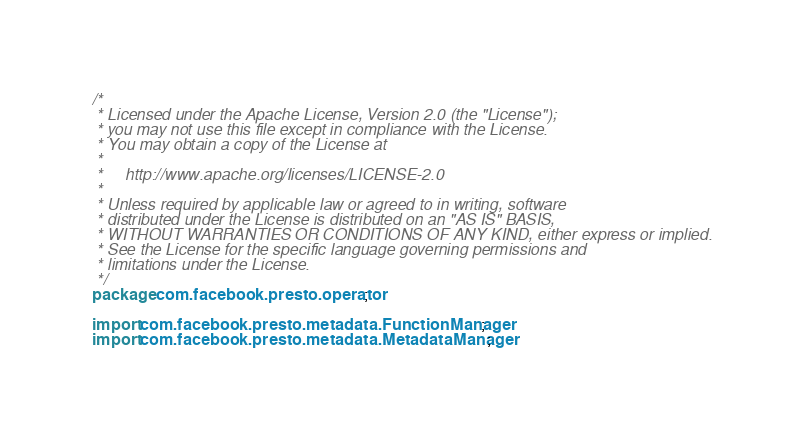<code> <loc_0><loc_0><loc_500><loc_500><_Java_>/*
 * Licensed under the Apache License, Version 2.0 (the "License");
 * you may not use this file except in compliance with the License.
 * You may obtain a copy of the License at
 *
 *     http://www.apache.org/licenses/LICENSE-2.0
 *
 * Unless required by applicable law or agreed to in writing, software
 * distributed under the License is distributed on an "AS IS" BASIS,
 * WITHOUT WARRANTIES OR CONDITIONS OF ANY KIND, either express or implied.
 * See the License for the specific language governing permissions and
 * limitations under the License.
 */
package com.facebook.presto.operator;

import com.facebook.presto.metadata.FunctionManager;
import com.facebook.presto.metadata.MetadataManager;</code> 